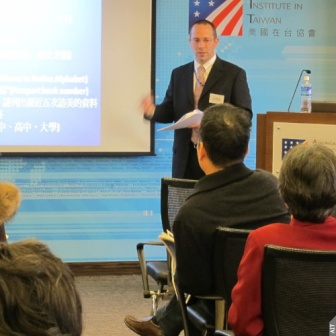What topics do you think are being discussed in the presentation? Given the context of the American Institute in Taiwan, the presentation could be discussing diplomatic relations, cultural exchange programs, educational collaborations, or bilateral trade agreements between the United States and Taiwan. The dual language presentation suggests a focus on topics relevant to both English and Chinese-speaking audiences. What might be the goals of this presentation? The goals of this presentation might include providing information about the American Institute in Taiwan's initiatives, promoting understanding and cooperation between the US and Taiwan, outlining upcoming events or collaborations, and engaging with a diverse audience to foster educational and cultural exchanges. 